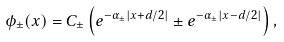Convert formula to latex. <formula><loc_0><loc_0><loc_500><loc_500>\phi _ { \pm } ( x ) = C _ { \pm } \left ( e ^ { - \alpha _ { \pm } | x + d / 2 | } \pm e ^ { - \alpha _ { \pm } | x - d / 2 | } \right ) ,</formula> 